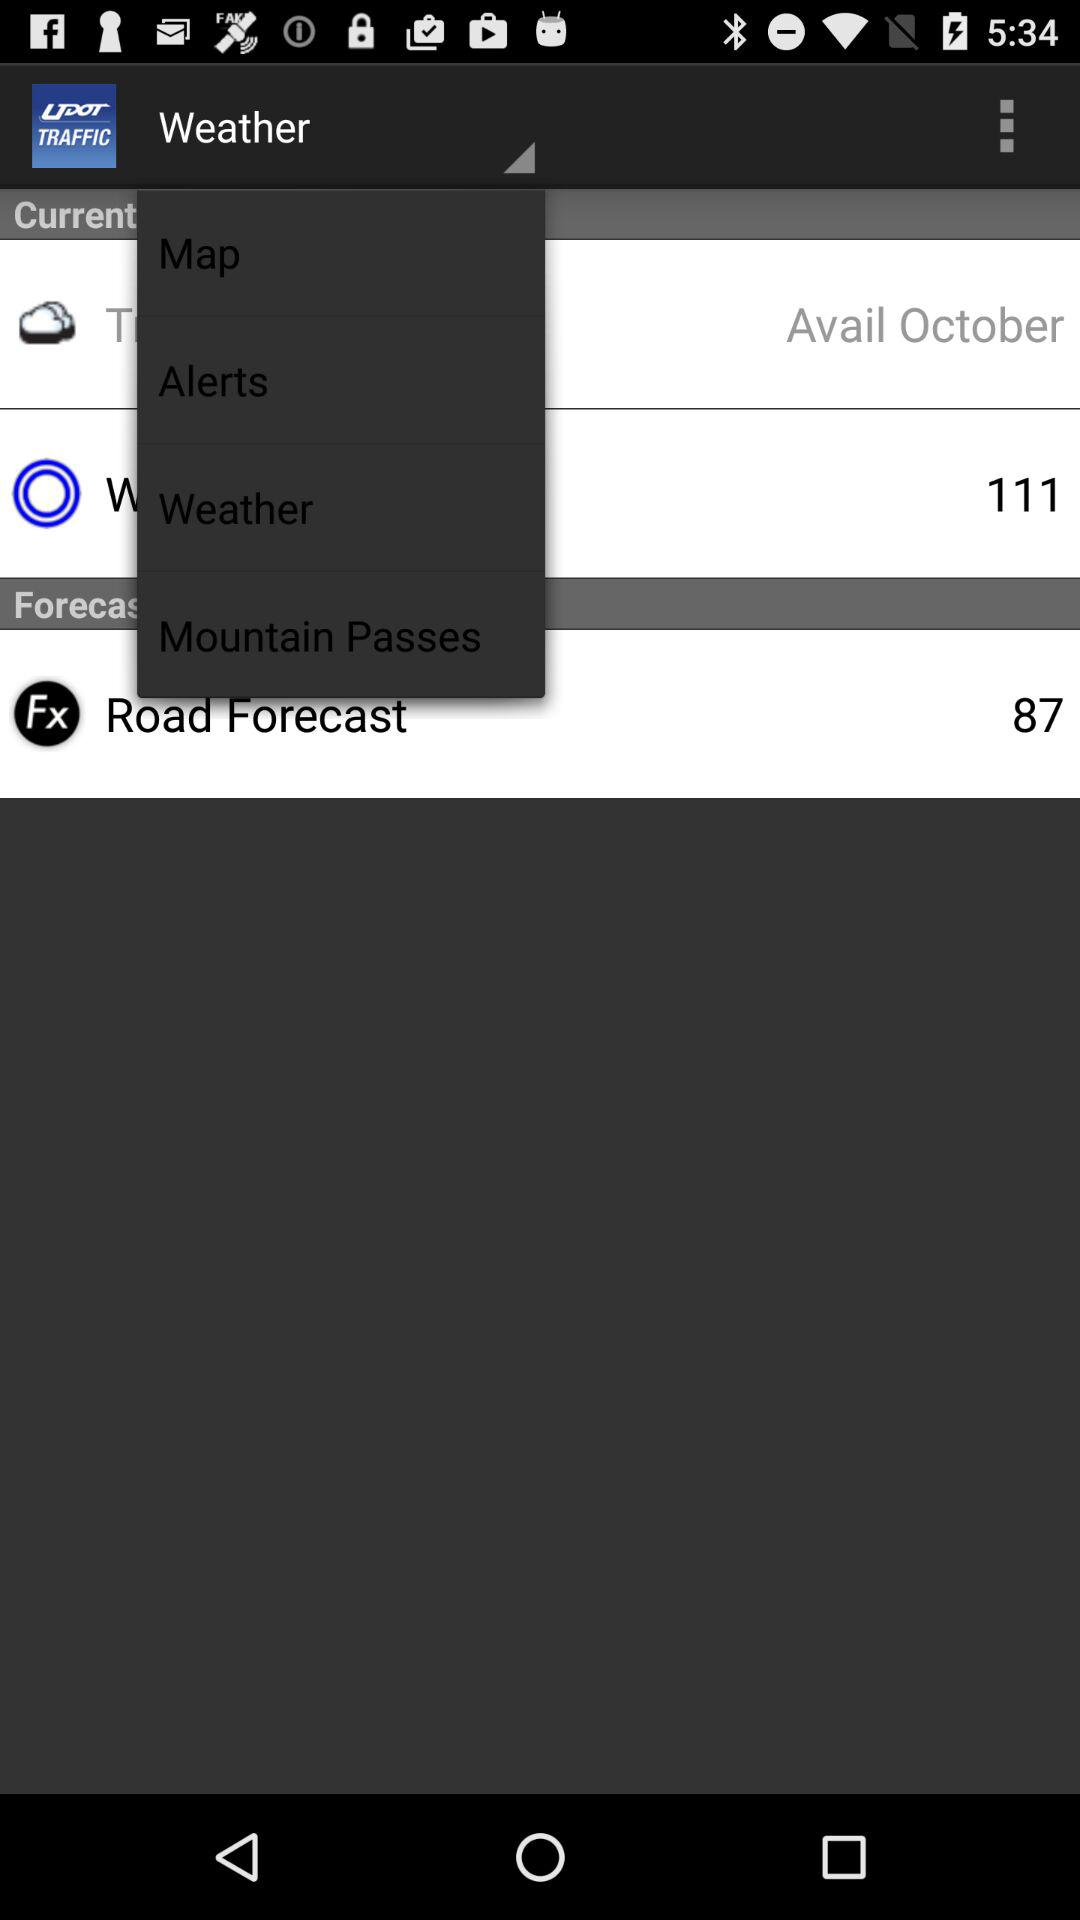What month is mentioned? The mentioned month is October. 